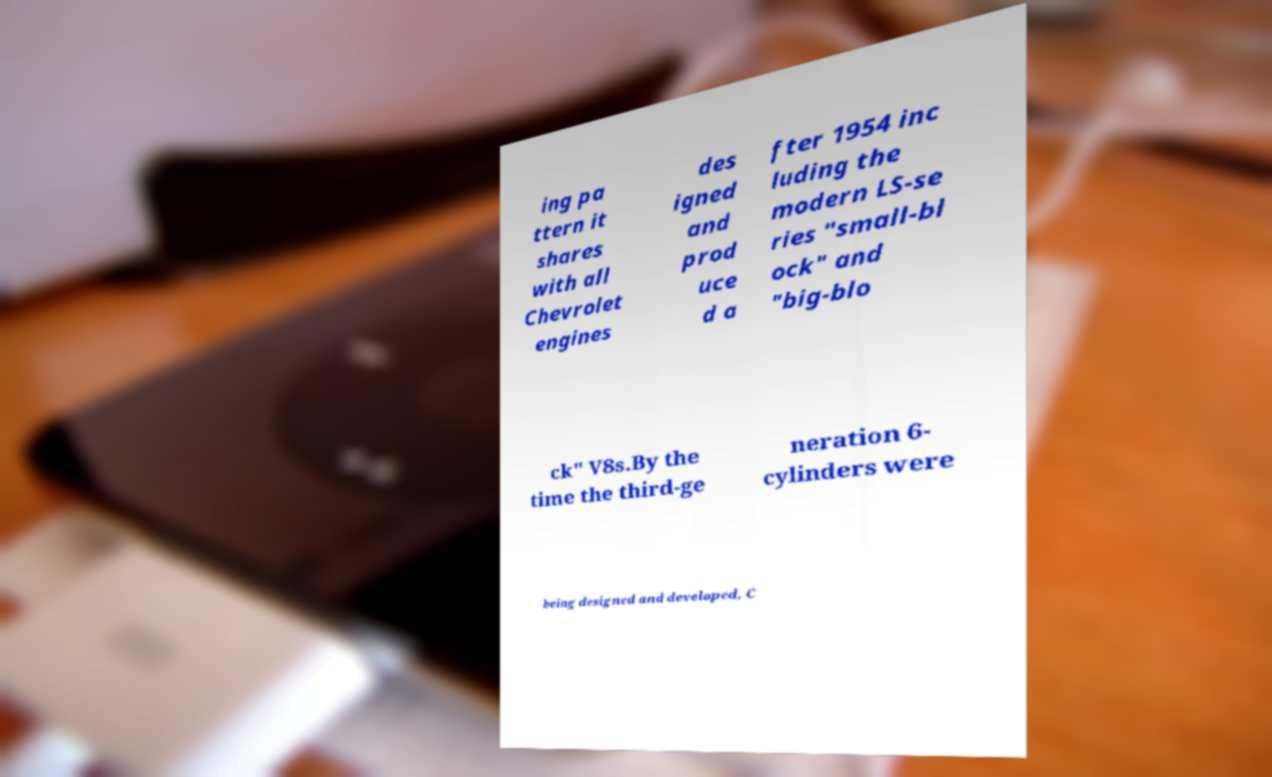Please read and relay the text visible in this image. What does it say? ing pa ttern it shares with all Chevrolet engines des igned and prod uce d a fter 1954 inc luding the modern LS-se ries "small-bl ock" and "big-blo ck" V8s.By the time the third-ge neration 6- cylinders were being designed and developed, C 